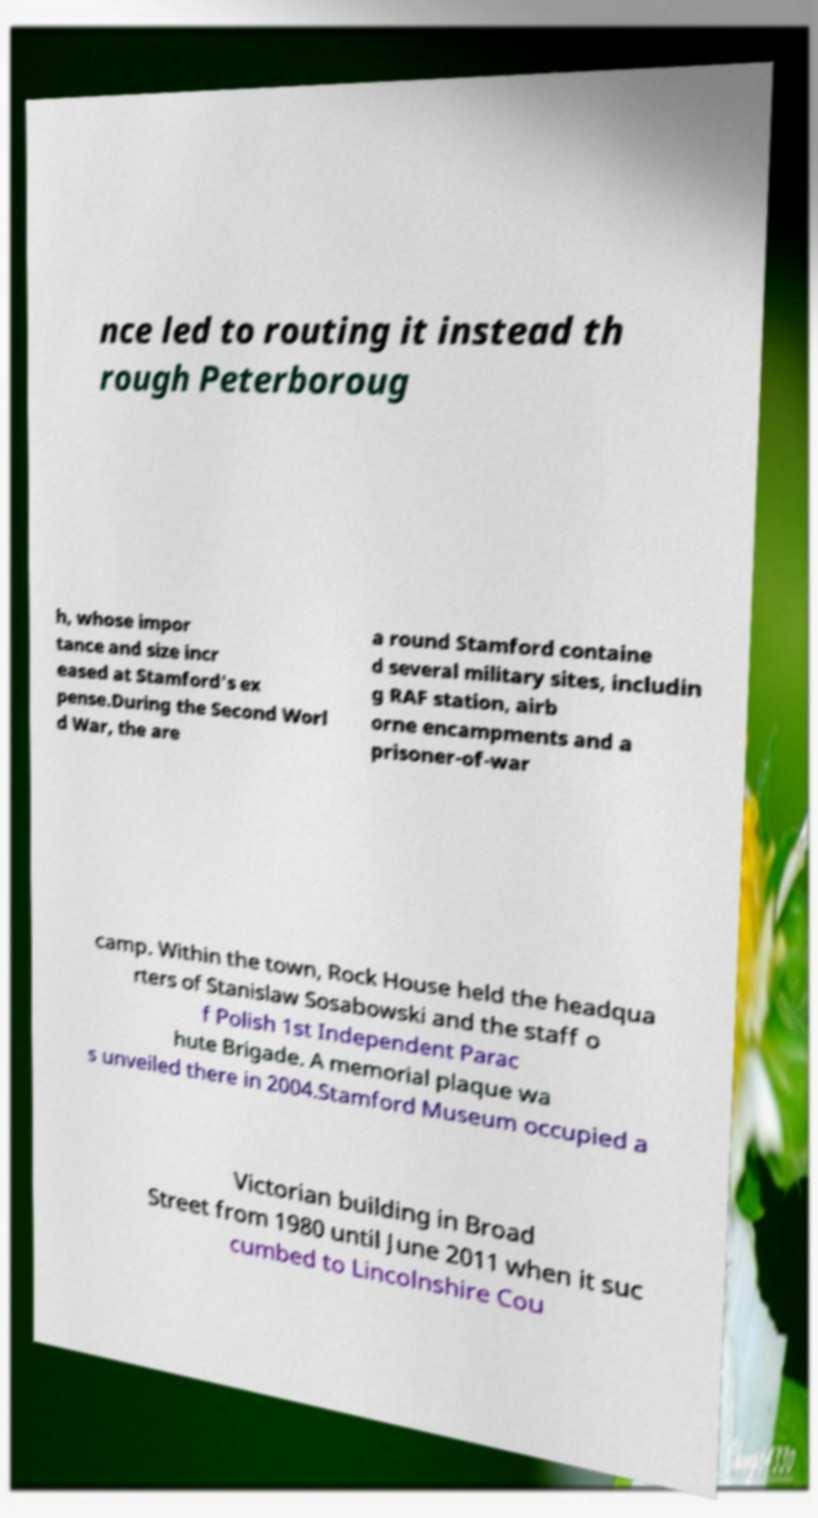What messages or text are displayed in this image? I need them in a readable, typed format. nce led to routing it instead th rough Peterboroug h, whose impor tance and size incr eased at Stamford's ex pense.During the Second Worl d War, the are a round Stamford containe d several military sites, includin g RAF station, airb orne encampments and a prisoner-of-war camp. Within the town, Rock House held the headqua rters of Stanislaw Sosabowski and the staff o f Polish 1st Independent Parac hute Brigade. A memorial plaque wa s unveiled there in 2004.Stamford Museum occupied a Victorian building in Broad Street from 1980 until June 2011 when it suc cumbed to Lincolnshire Cou 